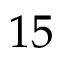<formula> <loc_0><loc_0><loc_500><loc_500>1 5</formula> 